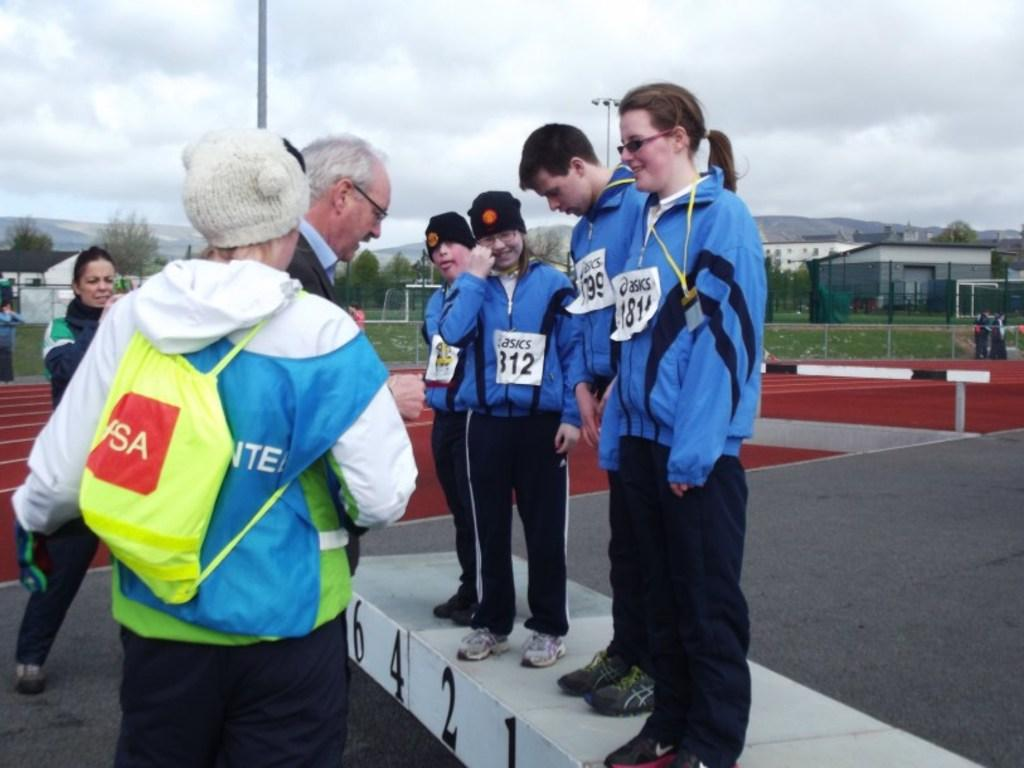<image>
Relay a brief, clear account of the picture shown. Four people in blue jackets are standing on a podium with name tags from asics. 